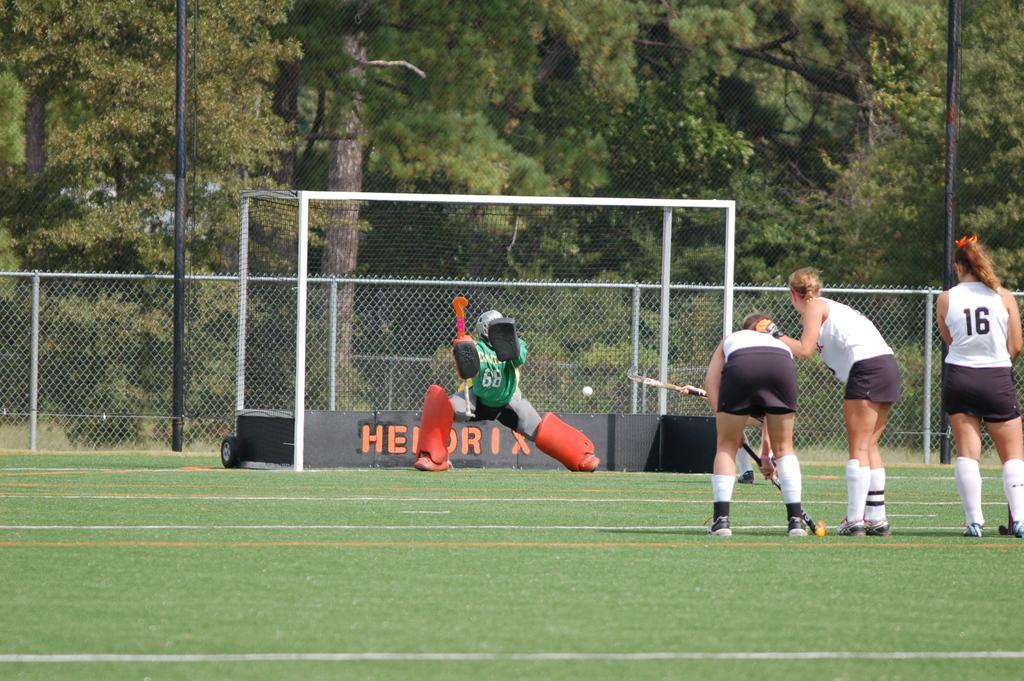<image>
Relay a brief, clear account of the picture shown. field hockey players on a field with the words hendrix in the goal 